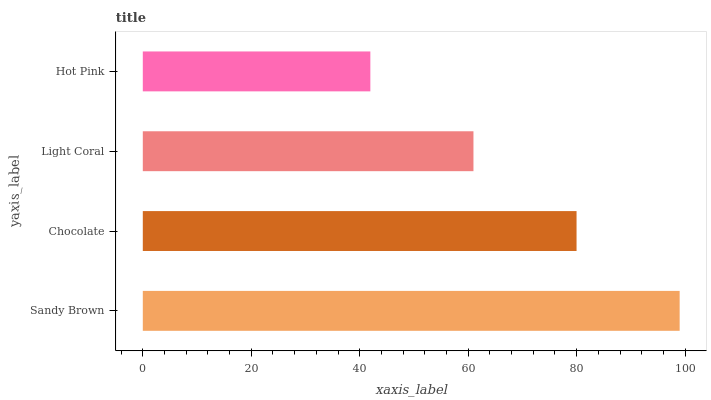Is Hot Pink the minimum?
Answer yes or no. Yes. Is Sandy Brown the maximum?
Answer yes or no. Yes. Is Chocolate the minimum?
Answer yes or no. No. Is Chocolate the maximum?
Answer yes or no. No. Is Sandy Brown greater than Chocolate?
Answer yes or no. Yes. Is Chocolate less than Sandy Brown?
Answer yes or no. Yes. Is Chocolate greater than Sandy Brown?
Answer yes or no. No. Is Sandy Brown less than Chocolate?
Answer yes or no. No. Is Chocolate the high median?
Answer yes or no. Yes. Is Light Coral the low median?
Answer yes or no. Yes. Is Light Coral the high median?
Answer yes or no. No. Is Chocolate the low median?
Answer yes or no. No. 